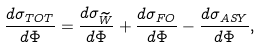<formula> <loc_0><loc_0><loc_500><loc_500>\frac { d \sigma _ { T O T } } { d \Phi } = \frac { d \sigma _ { \widetilde { W } } } { d \Phi } + \frac { d \sigma _ { F O } } { d \Phi } - \frac { d \sigma _ { A S Y } } { d \Phi } ,</formula> 